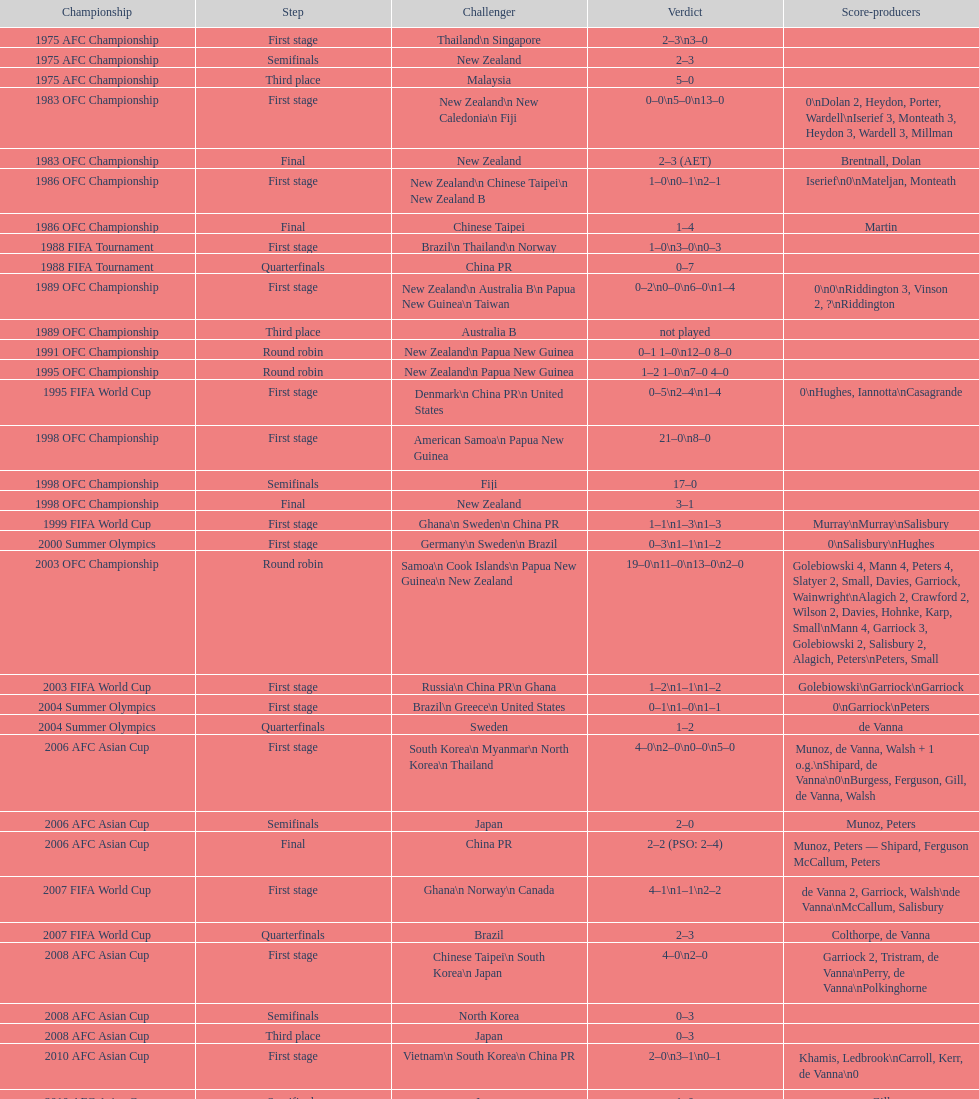Who was the last opponent this team faced in the 2010 afc asian cup? North Korea. 